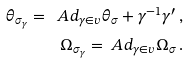<formula> <loc_0><loc_0><loc_500><loc_500>\theta _ { \sigma _ { \gamma } } = \ A d _ { \gamma \in v } \theta _ { \sigma } + \gamma ^ { - 1 } \gamma ^ { \prime } \, , \\ \Omega _ { \sigma _ { \gamma } } = \ A d _ { \gamma \in v } \Omega _ { \sigma } \, .</formula> 